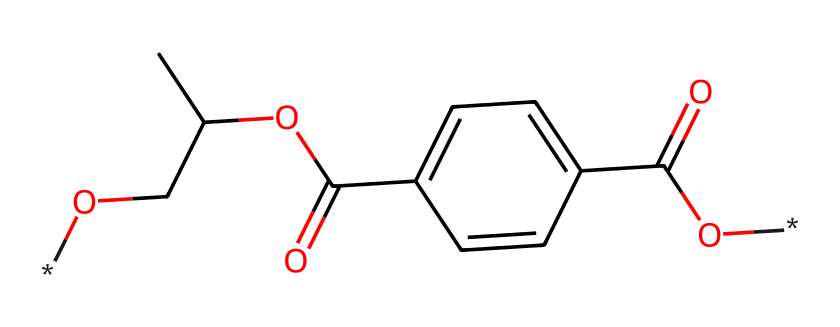What is the molecular formula of this compound? The SMILES representation includes several elements, each represented by their respective symbols. By examining the components, we identify the presence of Carbon (C), Oxygen (O), and Hydrogen (H). Counting these symbols gives us the molecular formula C10H10O4.
Answer: C10H10O4 How many aromatic rings does the structure contain? The chemical structure includes a benzene ring as indicated by the "c" notation, which represents aromatic carbon atoms. In this case, there is one aromatic ring present in the structure.
Answer: 1 What functional groups are present in this molecule? By examining the SMILES, we can identify that there are ester (denoted as R-COO-R) and carboxylic acid (–COOH) functional groups present in the structure. These can be recognized by the presence of a carbonyl group (C=O) attached to an oxygen or a hydroxyl group.
Answer: ester and carboxylic acid What type of polymer does this compound represent? The presence of multiple ester linkages and a repeating unit suggests that the compound is a thermoplastic polymer. Given its structures, it relates specifically to polyesters, primarily polyethylene terephthalate (PET), which is commonly used in plastic applications.
Answer: polyester What is the role of oxygen in this chemical structure? The presence of oxygen atoms indicates the presence of functional groups such as carbonyls and ether, which contribute to the chemical's properties like reactivity, solubility, and the formation of ester linkages in polymer chains affecting the material properties.
Answer: functional groups How many hydrogen atoms are attached to the benzene ring in this molecule? The benzene ring in this particular structure has two hydrogen atoms directly attached to it, as inferred from the absence of substitutions at their respective positions on the ring and the total hydrogen count derived from the full structure.
Answer: 2 